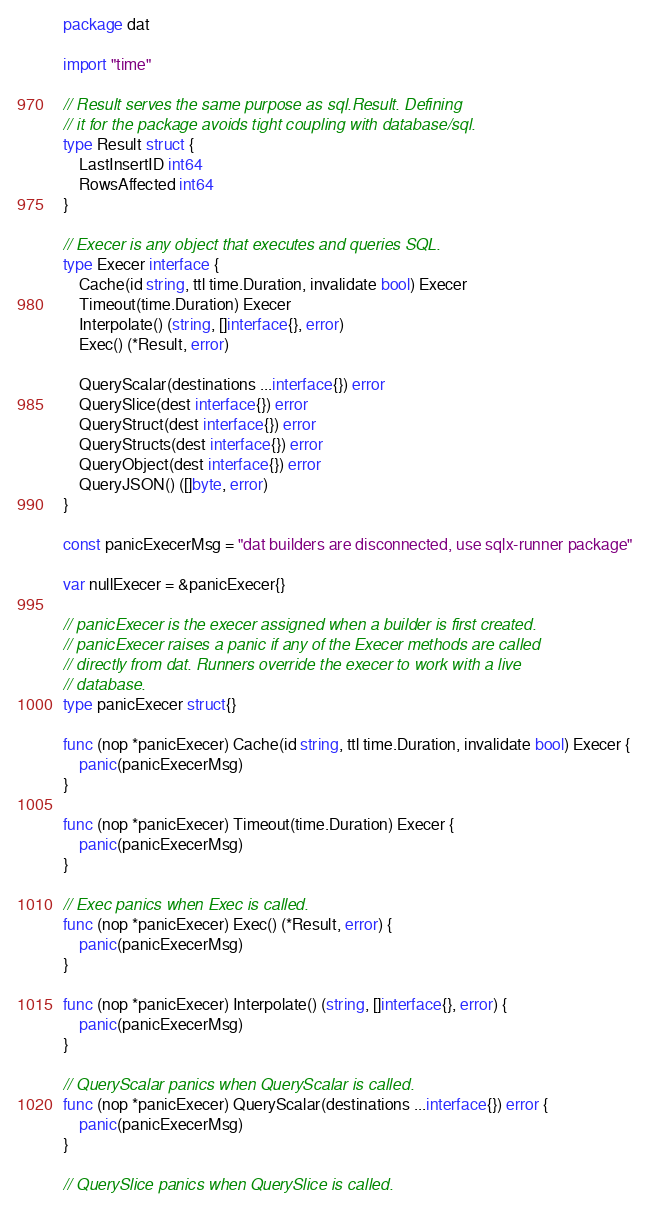<code> <loc_0><loc_0><loc_500><loc_500><_Go_>package dat

import "time"

// Result serves the same purpose as sql.Result. Defining
// it for the package avoids tight coupling with database/sql.
type Result struct {
	LastInsertID int64
	RowsAffected int64
}

// Execer is any object that executes and queries SQL.
type Execer interface {
	Cache(id string, ttl time.Duration, invalidate bool) Execer
	Timeout(time.Duration) Execer
	Interpolate() (string, []interface{}, error)
	Exec() (*Result, error)

	QueryScalar(destinations ...interface{}) error
	QuerySlice(dest interface{}) error
	QueryStruct(dest interface{}) error
	QueryStructs(dest interface{}) error
	QueryObject(dest interface{}) error
	QueryJSON() ([]byte, error)
}

const panicExecerMsg = "dat builders are disconnected, use sqlx-runner package"

var nullExecer = &panicExecer{}

// panicExecer is the execer assigned when a builder is first created.
// panicExecer raises a panic if any of the Execer methods are called
// directly from dat. Runners override the execer to work with a live
// database.
type panicExecer struct{}

func (nop *panicExecer) Cache(id string, ttl time.Duration, invalidate bool) Execer {
	panic(panicExecerMsg)
}

func (nop *panicExecer) Timeout(time.Duration) Execer {
	panic(panicExecerMsg)
}

// Exec panics when Exec is called.
func (nop *panicExecer) Exec() (*Result, error) {
	panic(panicExecerMsg)
}

func (nop *panicExecer) Interpolate() (string, []interface{}, error) {
	panic(panicExecerMsg)
}

// QueryScalar panics when QueryScalar is called.
func (nop *panicExecer) QueryScalar(destinations ...interface{}) error {
	panic(panicExecerMsg)
}

// QuerySlice panics when QuerySlice is called.</code> 